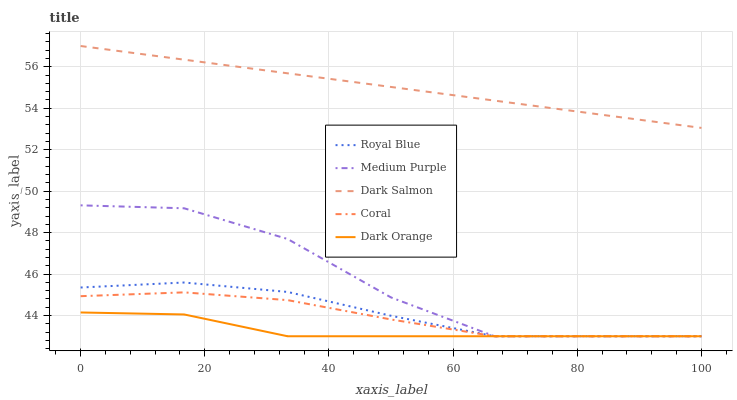Does Dark Orange have the minimum area under the curve?
Answer yes or no. Yes. Does Dark Salmon have the maximum area under the curve?
Answer yes or no. Yes. Does Royal Blue have the minimum area under the curve?
Answer yes or no. No. Does Royal Blue have the maximum area under the curve?
Answer yes or no. No. Is Dark Salmon the smoothest?
Answer yes or no. Yes. Is Medium Purple the roughest?
Answer yes or no. Yes. Is Royal Blue the smoothest?
Answer yes or no. No. Is Royal Blue the roughest?
Answer yes or no. No. Does Medium Purple have the lowest value?
Answer yes or no. Yes. Does Dark Salmon have the lowest value?
Answer yes or no. No. Does Dark Salmon have the highest value?
Answer yes or no. Yes. Does Royal Blue have the highest value?
Answer yes or no. No. Is Coral less than Dark Salmon?
Answer yes or no. Yes. Is Dark Salmon greater than Coral?
Answer yes or no. Yes. Does Royal Blue intersect Dark Orange?
Answer yes or no. Yes. Is Royal Blue less than Dark Orange?
Answer yes or no. No. Is Royal Blue greater than Dark Orange?
Answer yes or no. No. Does Coral intersect Dark Salmon?
Answer yes or no. No. 